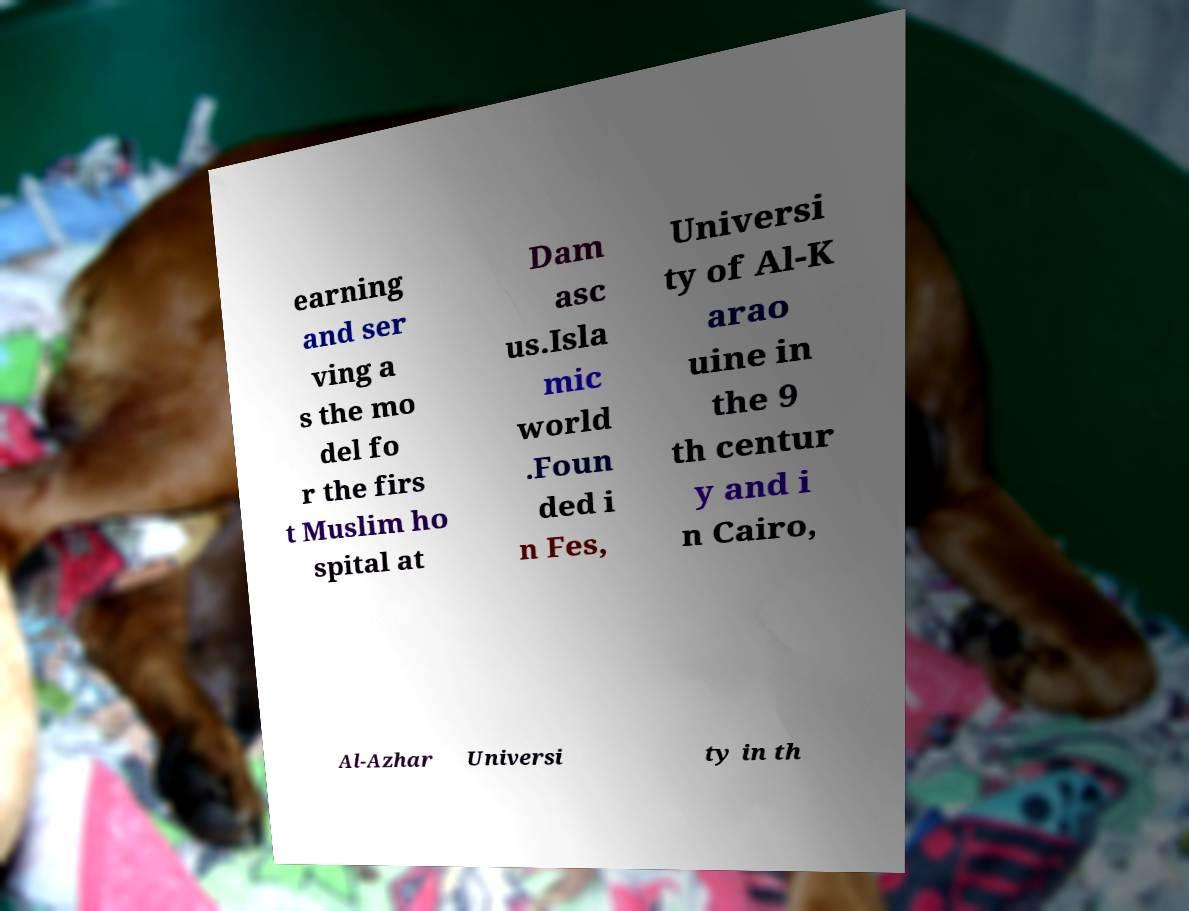There's text embedded in this image that I need extracted. Can you transcribe it verbatim? earning and ser ving a s the mo del fo r the firs t Muslim ho spital at Dam asc us.Isla mic world .Foun ded i n Fes, Universi ty of Al-K arao uine in the 9 th centur y and i n Cairo, Al-Azhar Universi ty in th 